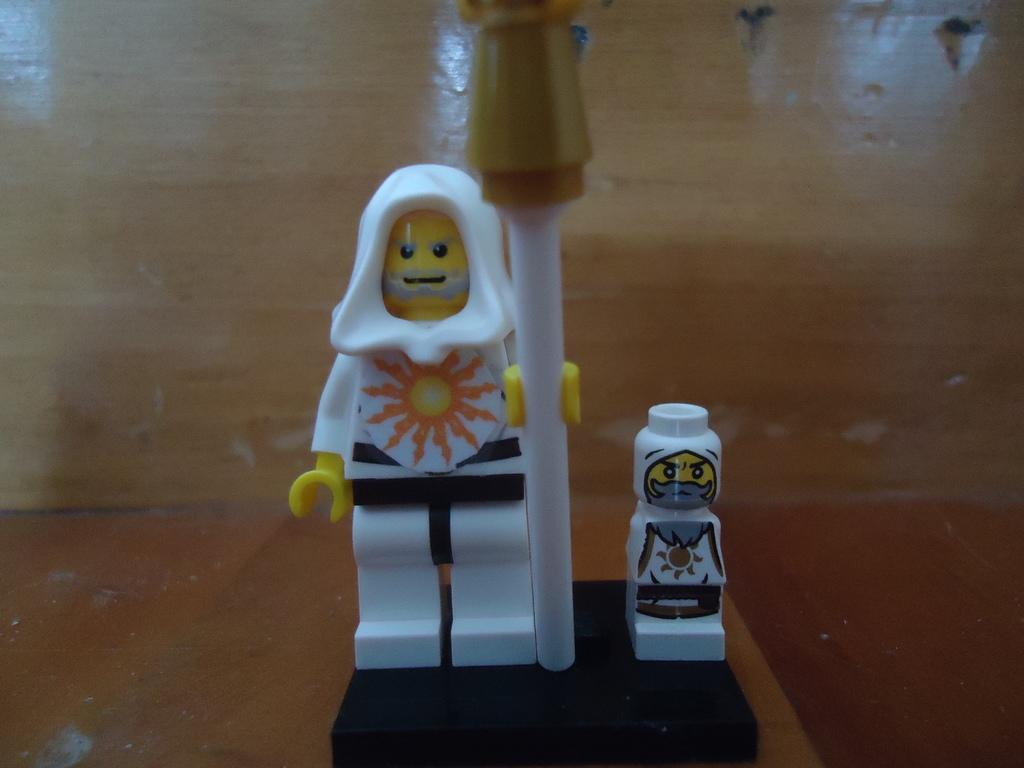What objects are in the front of the image? There are two toys in the front of the image. Can you describe the location of the toys in the image? The toys are in the front of the image. What material is visible in the background of the image? There is plywood in the background of the image. Can you tell me how many snails are crawling on the toys in the image? There are no snails present in the image; it only features two toys. What type of medical facility is visible in the image? There is no hospital present in the image. 